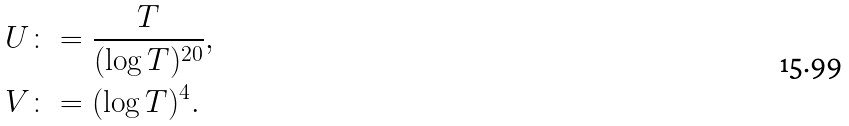<formula> <loc_0><loc_0><loc_500><loc_500>U & \colon = \frac { T } { ( \log T ) ^ { 2 0 } } , \\ V & \colon = ( \log T ) ^ { 4 } .</formula> 